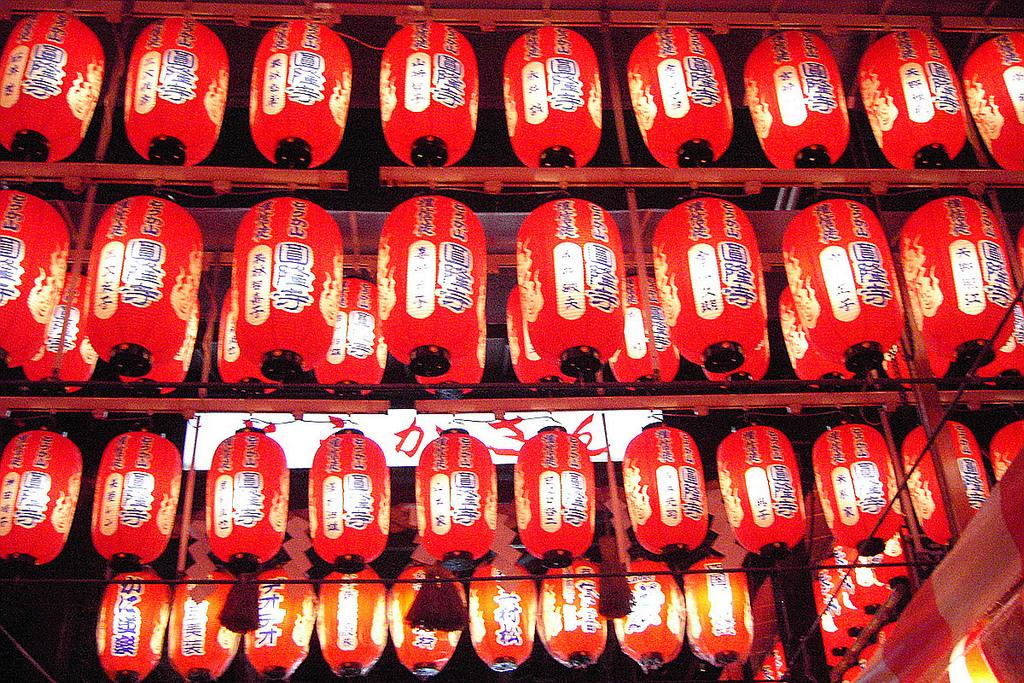What type of decorations are present in the image? There are Chinese lanterns in the image. What can be seen on the Chinese lanterns? Words are written on the Chinese lanterns. What color are the Chinese lanterns? The Chinese lanterns are red in color. What type of window is visible in the image? There is no window present in the image; it features Chinese lanterns. How does the wound on the person's arm look in the image? There is no person or wound present in the image; it features Chinese lanterns. 